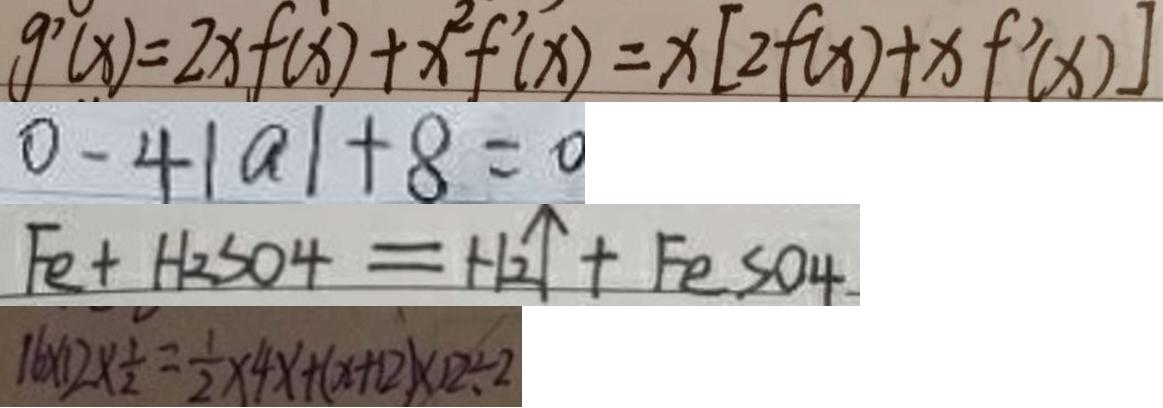Convert formula to latex. <formula><loc_0><loc_0><loc_500><loc_500>g ^ { \prime } ( x ) = 2 x f ( x ) + x ^ { 2 } f ^ { \prime } ( x ) = x [ 2 f ( x ) + x f ^ { \prime } ( x ) ] 
 0 - 4 \vert a \vert + 8 = 0 
 F e + H _ { 2 } S O _ { 4 } = H _ { 2 } \uparrow + F e S 0 4 
 1 6 \times 1 2 \times \frac { 1 } { 2 } = \frac { 1 } { 2 } \times 4 x + ( x + 1 2 ) \times 1 2 \div 2</formula> 